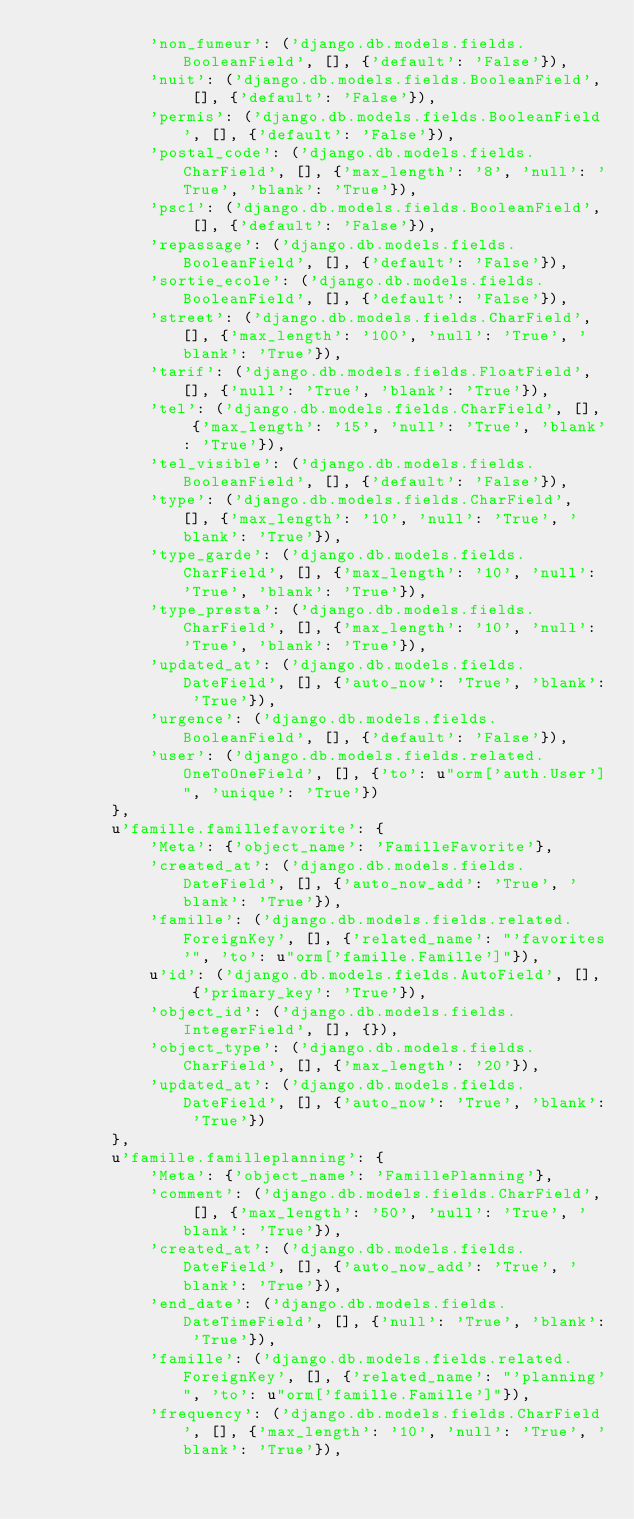Convert code to text. <code><loc_0><loc_0><loc_500><loc_500><_Python_>            'non_fumeur': ('django.db.models.fields.BooleanField', [], {'default': 'False'}),
            'nuit': ('django.db.models.fields.BooleanField', [], {'default': 'False'}),
            'permis': ('django.db.models.fields.BooleanField', [], {'default': 'False'}),
            'postal_code': ('django.db.models.fields.CharField', [], {'max_length': '8', 'null': 'True', 'blank': 'True'}),
            'psc1': ('django.db.models.fields.BooleanField', [], {'default': 'False'}),
            'repassage': ('django.db.models.fields.BooleanField', [], {'default': 'False'}),
            'sortie_ecole': ('django.db.models.fields.BooleanField', [], {'default': 'False'}),
            'street': ('django.db.models.fields.CharField', [], {'max_length': '100', 'null': 'True', 'blank': 'True'}),
            'tarif': ('django.db.models.fields.FloatField', [], {'null': 'True', 'blank': 'True'}),
            'tel': ('django.db.models.fields.CharField', [], {'max_length': '15', 'null': 'True', 'blank': 'True'}),
            'tel_visible': ('django.db.models.fields.BooleanField', [], {'default': 'False'}),
            'type': ('django.db.models.fields.CharField', [], {'max_length': '10', 'null': 'True', 'blank': 'True'}),
            'type_garde': ('django.db.models.fields.CharField', [], {'max_length': '10', 'null': 'True', 'blank': 'True'}),
            'type_presta': ('django.db.models.fields.CharField', [], {'max_length': '10', 'null': 'True', 'blank': 'True'}),
            'updated_at': ('django.db.models.fields.DateField', [], {'auto_now': 'True', 'blank': 'True'}),
            'urgence': ('django.db.models.fields.BooleanField', [], {'default': 'False'}),
            'user': ('django.db.models.fields.related.OneToOneField', [], {'to': u"orm['auth.User']", 'unique': 'True'})
        },
        u'famille.famillefavorite': {
            'Meta': {'object_name': 'FamilleFavorite'},
            'created_at': ('django.db.models.fields.DateField', [], {'auto_now_add': 'True', 'blank': 'True'}),
            'famille': ('django.db.models.fields.related.ForeignKey', [], {'related_name': "'favorites'", 'to': u"orm['famille.Famille']"}),
            u'id': ('django.db.models.fields.AutoField', [], {'primary_key': 'True'}),
            'object_id': ('django.db.models.fields.IntegerField', [], {}),
            'object_type': ('django.db.models.fields.CharField', [], {'max_length': '20'}),
            'updated_at': ('django.db.models.fields.DateField', [], {'auto_now': 'True', 'blank': 'True'})
        },
        u'famille.familleplanning': {
            'Meta': {'object_name': 'FamillePlanning'},
            'comment': ('django.db.models.fields.CharField', [], {'max_length': '50', 'null': 'True', 'blank': 'True'}),
            'created_at': ('django.db.models.fields.DateField', [], {'auto_now_add': 'True', 'blank': 'True'}),
            'end_date': ('django.db.models.fields.DateTimeField', [], {'null': 'True', 'blank': 'True'}),
            'famille': ('django.db.models.fields.related.ForeignKey', [], {'related_name': "'planning'", 'to': u"orm['famille.Famille']"}),
            'frequency': ('django.db.models.fields.CharField', [], {'max_length': '10', 'null': 'True', 'blank': 'True'}),</code> 